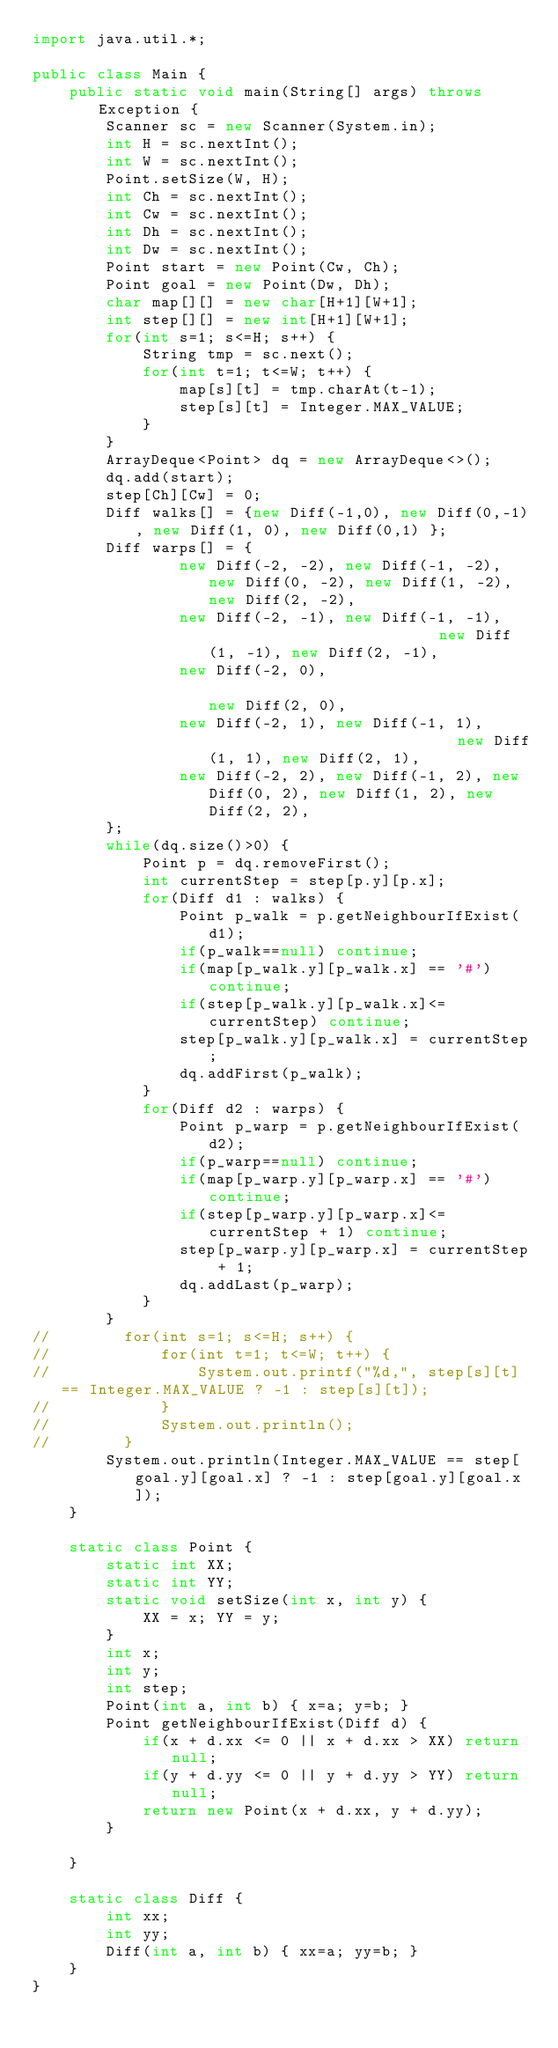<code> <loc_0><loc_0><loc_500><loc_500><_Java_>import java.util.*;

public class Main {
    public static void main(String[] args) throws Exception {
        Scanner sc = new Scanner(System.in);
        int H = sc.nextInt();
        int W = sc.nextInt();
        Point.setSize(W, H);
        int Ch = sc.nextInt();
        int Cw = sc.nextInt();
        int Dh = sc.nextInt();
        int Dw = sc.nextInt();
        Point start = new Point(Cw, Ch);
        Point goal = new Point(Dw, Dh);
        char map[][] = new char[H+1][W+1];
        int step[][] = new int[H+1][W+1];
        for(int s=1; s<=H; s++) {
            String tmp = sc.next();
            for(int t=1; t<=W; t++) {
                map[s][t] = tmp.charAt(t-1);
                step[s][t] = Integer.MAX_VALUE;
            }
        }
        ArrayDeque<Point> dq = new ArrayDeque<>();
        dq.add(start);
        step[Ch][Cw] = 0;
        Diff walks[] = {new Diff(-1,0), new Diff(0,-1), new Diff(1, 0), new Diff(0,1) };
        Diff warps[] = {
                new Diff(-2, -2), new Diff(-1, -2), new Diff(0, -2), new Diff(1, -2), new Diff(2, -2),
                new Diff(-2, -1), new Diff(-1, -1),                          new Diff(1, -1), new Diff(2, -1),
                new Diff(-2, 0),                                                                              new Diff(2, 0),
                new Diff(-2, 1), new Diff(-1, 1),                            new Diff(1, 1), new Diff(2, 1),
                new Diff(-2, 2), new Diff(-1, 2), new Diff(0, 2), new Diff(1, 2), new Diff(2, 2),
        };
        while(dq.size()>0) {
            Point p = dq.removeFirst();
            int currentStep = step[p.y][p.x];
            for(Diff d1 : walks) {
                Point p_walk = p.getNeighbourIfExist(d1);
                if(p_walk==null) continue;
                if(map[p_walk.y][p_walk.x] == '#') continue;
                if(step[p_walk.y][p_walk.x]<= currentStep) continue;
                step[p_walk.y][p_walk.x] = currentStep;
                dq.addFirst(p_walk);
            }
            for(Diff d2 : warps) {
                Point p_warp = p.getNeighbourIfExist(d2);
                if(p_warp==null) continue;
                if(map[p_warp.y][p_warp.x] == '#') continue;
                if(step[p_warp.y][p_warp.x]<=currentStep + 1) continue;
                step[p_warp.y][p_warp.x] = currentStep + 1;
                dq.addLast(p_warp);
            }
        }
//        for(int s=1; s<=H; s++) {
//            for(int t=1; t<=W; t++) {
//                System.out.printf("%d,", step[s][t] == Integer.MAX_VALUE ? -1 : step[s][t]);
//            }
//            System.out.println();
//        }
        System.out.println(Integer.MAX_VALUE == step[goal.y][goal.x] ? -1 : step[goal.y][goal.x]);
    }

    static class Point {
        static int XX;
        static int YY;
        static void setSize(int x, int y) {
            XX = x; YY = y;
        }
        int x;
        int y;
        int step;
        Point(int a, int b) { x=a; y=b; }
        Point getNeighbourIfExist(Diff d) {
            if(x + d.xx <= 0 || x + d.xx > XX) return null;
            if(y + d.yy <= 0 || y + d.yy > YY) return null;
            return new Point(x + d.xx, y + d.yy);
        }

    }

    static class Diff {
        int xx;
        int yy;
        Diff(int a, int b) { xx=a; yy=b; }
    }
}
</code> 